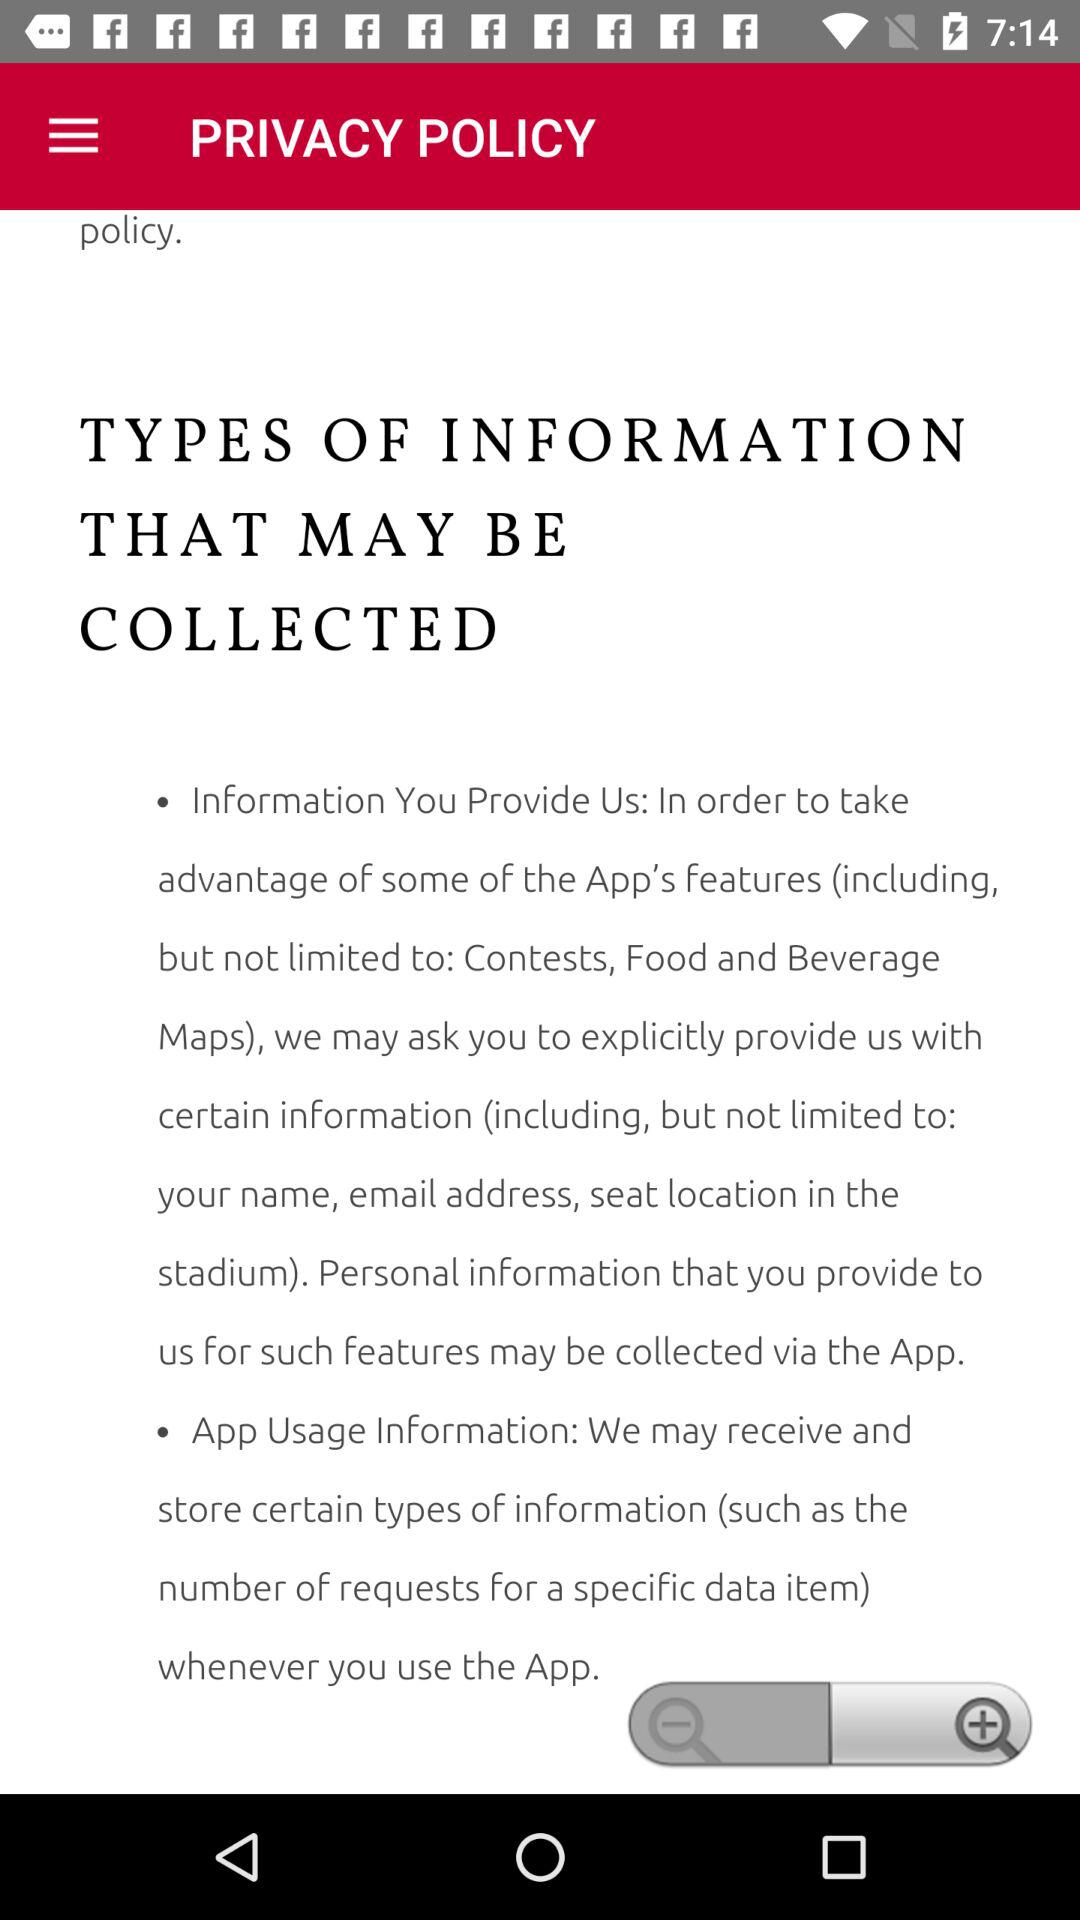How many types of information are collected?
Answer the question using a single word or phrase. 2 